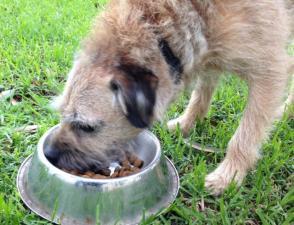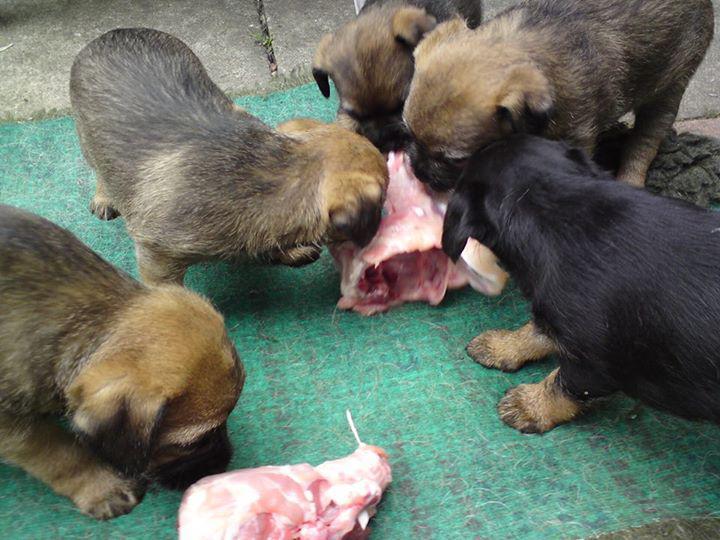The first image is the image on the left, the second image is the image on the right. Considering the images on both sides, is "Each image shows one guinea pig to the left of one puppy, and the right image shows a guinea pig overlapping a sitting puppy." valid? Answer yes or no. No. The first image is the image on the left, the second image is the image on the right. Analyze the images presented: Is the assertion "There are exactly two dogs and two guinea pigs." valid? Answer yes or no. No. 